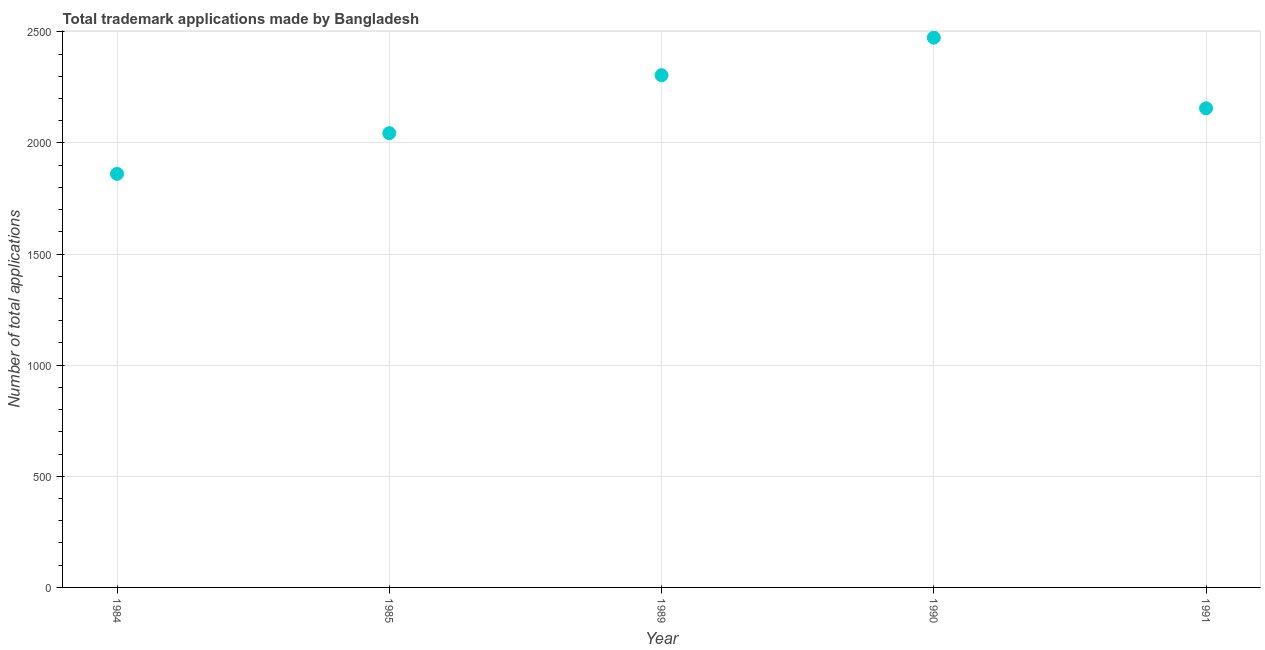What is the number of trademark applications in 1985?
Your response must be concise. 2044. Across all years, what is the maximum number of trademark applications?
Offer a very short reply. 2474. Across all years, what is the minimum number of trademark applications?
Ensure brevity in your answer.  1861. In which year was the number of trademark applications maximum?
Keep it short and to the point. 1990. What is the sum of the number of trademark applications?
Make the answer very short. 1.08e+04. What is the difference between the number of trademark applications in 1984 and 1990?
Ensure brevity in your answer.  -613. What is the average number of trademark applications per year?
Make the answer very short. 2168. What is the median number of trademark applications?
Give a very brief answer. 2156. Do a majority of the years between 1984 and 1985 (inclusive) have number of trademark applications greater than 600 ?
Give a very brief answer. Yes. What is the ratio of the number of trademark applications in 1989 to that in 1990?
Offer a very short reply. 0.93. Is the number of trademark applications in 1984 less than that in 1990?
Ensure brevity in your answer.  Yes. Is the difference between the number of trademark applications in 1984 and 1990 greater than the difference between any two years?
Your answer should be compact. Yes. What is the difference between the highest and the second highest number of trademark applications?
Give a very brief answer. 169. What is the difference between the highest and the lowest number of trademark applications?
Offer a very short reply. 613. How many years are there in the graph?
Offer a terse response. 5. What is the difference between two consecutive major ticks on the Y-axis?
Offer a very short reply. 500. Does the graph contain any zero values?
Ensure brevity in your answer.  No. Does the graph contain grids?
Make the answer very short. Yes. What is the title of the graph?
Make the answer very short. Total trademark applications made by Bangladesh. What is the label or title of the X-axis?
Ensure brevity in your answer.  Year. What is the label or title of the Y-axis?
Make the answer very short. Number of total applications. What is the Number of total applications in 1984?
Offer a very short reply. 1861. What is the Number of total applications in 1985?
Provide a succinct answer. 2044. What is the Number of total applications in 1989?
Offer a terse response. 2305. What is the Number of total applications in 1990?
Ensure brevity in your answer.  2474. What is the Number of total applications in 1991?
Offer a terse response. 2156. What is the difference between the Number of total applications in 1984 and 1985?
Your answer should be compact. -183. What is the difference between the Number of total applications in 1984 and 1989?
Make the answer very short. -444. What is the difference between the Number of total applications in 1984 and 1990?
Make the answer very short. -613. What is the difference between the Number of total applications in 1984 and 1991?
Your response must be concise. -295. What is the difference between the Number of total applications in 1985 and 1989?
Give a very brief answer. -261. What is the difference between the Number of total applications in 1985 and 1990?
Make the answer very short. -430. What is the difference between the Number of total applications in 1985 and 1991?
Give a very brief answer. -112. What is the difference between the Number of total applications in 1989 and 1990?
Ensure brevity in your answer.  -169. What is the difference between the Number of total applications in 1989 and 1991?
Make the answer very short. 149. What is the difference between the Number of total applications in 1990 and 1991?
Your answer should be very brief. 318. What is the ratio of the Number of total applications in 1984 to that in 1985?
Provide a succinct answer. 0.91. What is the ratio of the Number of total applications in 1984 to that in 1989?
Your answer should be very brief. 0.81. What is the ratio of the Number of total applications in 1984 to that in 1990?
Offer a very short reply. 0.75. What is the ratio of the Number of total applications in 1984 to that in 1991?
Your answer should be compact. 0.86. What is the ratio of the Number of total applications in 1985 to that in 1989?
Keep it short and to the point. 0.89. What is the ratio of the Number of total applications in 1985 to that in 1990?
Make the answer very short. 0.83. What is the ratio of the Number of total applications in 1985 to that in 1991?
Make the answer very short. 0.95. What is the ratio of the Number of total applications in 1989 to that in 1990?
Provide a succinct answer. 0.93. What is the ratio of the Number of total applications in 1989 to that in 1991?
Your answer should be compact. 1.07. What is the ratio of the Number of total applications in 1990 to that in 1991?
Your response must be concise. 1.15. 